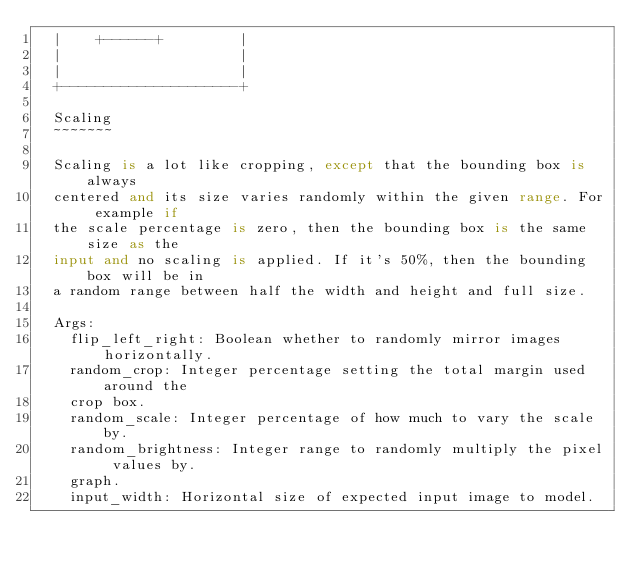<code> <loc_0><loc_0><loc_500><loc_500><_Python_>  |    +------+         |
  |                     |
  |                     |
  +---------------------+

  Scaling
  ~~~~~~~

  Scaling is a lot like cropping, except that the bounding box is always
  centered and its size varies randomly within the given range. For example if
  the scale percentage is zero, then the bounding box is the same size as the
  input and no scaling is applied. If it's 50%, then the bounding box will be in
  a random range between half the width and height and full size.

  Args:
    flip_left_right: Boolean whether to randomly mirror images horizontally.
    random_crop: Integer percentage setting the total margin used around the
    crop box.
    random_scale: Integer percentage of how much to vary the scale by.
    random_brightness: Integer range to randomly multiply the pixel values by.
    graph.
    input_width: Horizontal size of expected input image to model.</code> 